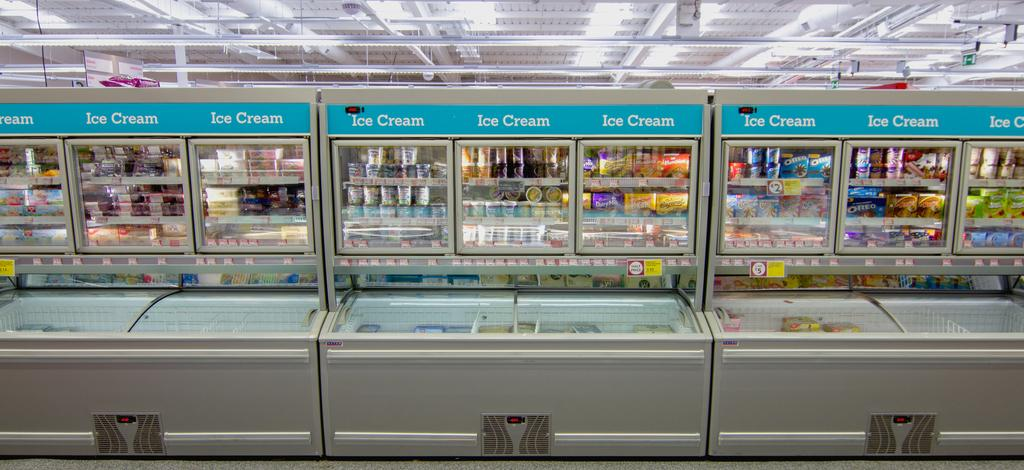<image>
Describe the image concisely. a large display of ICE CREAM coolers in a store 